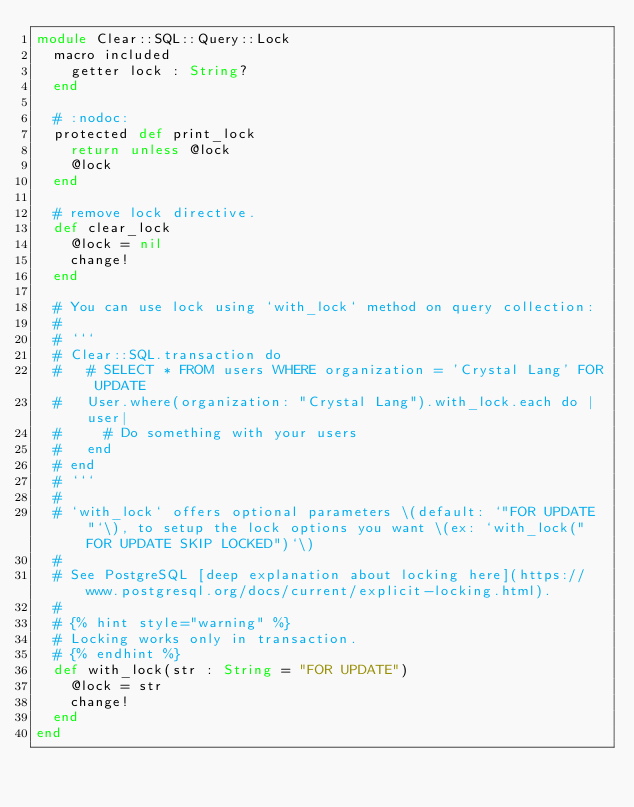Convert code to text. <code><loc_0><loc_0><loc_500><loc_500><_Crystal_>module Clear::SQL::Query::Lock
  macro included
    getter lock : String?
  end

  # :nodoc:
  protected def print_lock
    return unless @lock
    @lock
  end

  # remove lock directive.
  def clear_lock
    @lock = nil
    change!
  end

  # You can use lock using `with_lock` method on query collection:
  #
  # ```
  # Clear::SQL.transaction do
  #   # SELECT * FROM users WHERE organization = 'Crystal Lang' FOR UPDATE
  #   User.where(organization: "Crystal Lang").with_lock.each do |user|
  #     # Do something with your users
  #   end
  # end
  # ```
  #
  # `with_lock` offers optional parameters \(default: `"FOR UPDATE"`\), to setup the lock options you want \(ex: `with_lock("FOR UPDATE SKIP LOCKED")`\)
  #
  # See PostgreSQL [deep explanation about locking here](https://www.postgresql.org/docs/current/explicit-locking.html).
  #
  # {% hint style="warning" %}
  # Locking works only in transaction.
  # {% endhint %}
  def with_lock(str : String = "FOR UPDATE")
    @lock = str
    change!
  end
end
</code> 